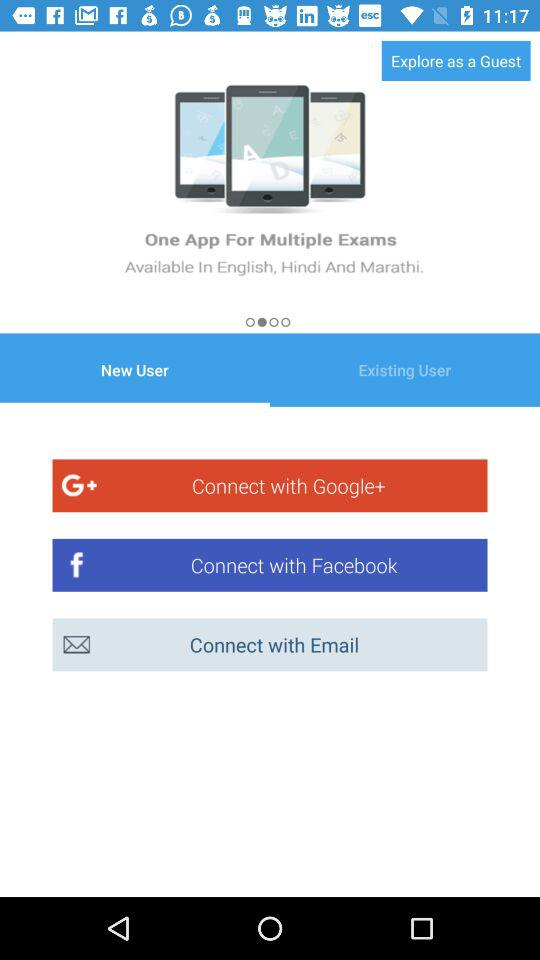How many languages are available on the app?
Answer the question using a single word or phrase. 3 